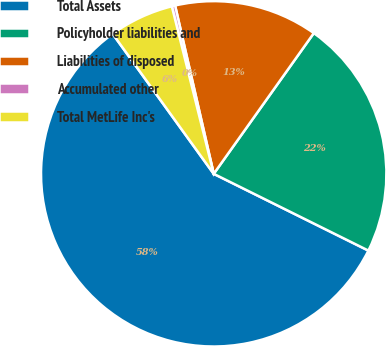Convert chart to OTSL. <chart><loc_0><loc_0><loc_500><loc_500><pie_chart><fcel>Total Assets<fcel>Policyholder liabilities and<fcel>Liabilities of disposed<fcel>Accumulated other<fcel>Total MetLife Inc's<nl><fcel>57.71%<fcel>22.49%<fcel>13.43%<fcel>0.31%<fcel>6.05%<nl></chart> 